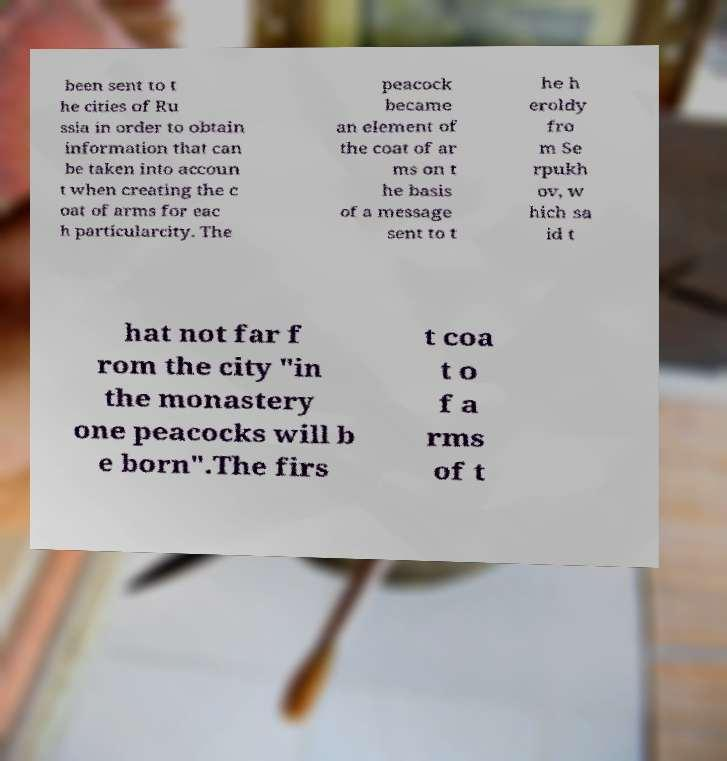There's text embedded in this image that I need extracted. Can you transcribe it verbatim? been sent to t he cities of Ru ssia in order to obtain information that can be taken into accoun t when creating the c oat of arms for eac h particularcity. The peacock became an element of the coat of ar ms on t he basis of a message sent to t he h eroldy fro m Se rpukh ov, w hich sa id t hat not far f rom the city "in the monastery one peacocks will b e born".The firs t coa t o f a rms of t 